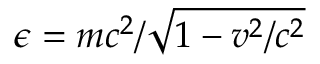Convert formula to latex. <formula><loc_0><loc_0><loc_500><loc_500>\epsilon = m c ^ { 2 } / \sqrt { 1 - v ^ { 2 } / c ^ { 2 } }</formula> 